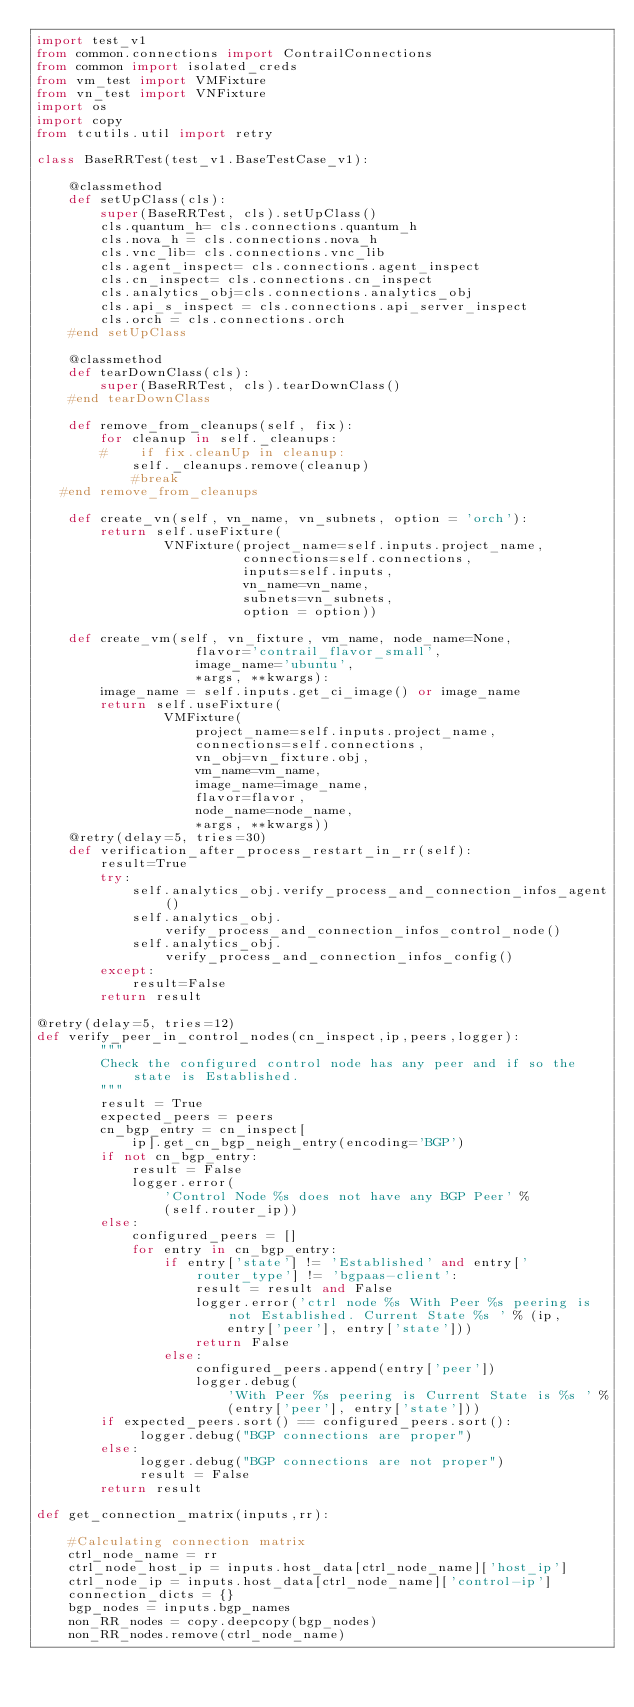<code> <loc_0><loc_0><loc_500><loc_500><_Python_>import test_v1
from common.connections import ContrailConnections
from common import isolated_creds
from vm_test import VMFixture
from vn_test import VNFixture
import os
import copy
from tcutils.util import retry

class BaseRRTest(test_v1.BaseTestCase_v1):

    @classmethod
    def setUpClass(cls):
        super(BaseRRTest, cls).setUpClass()
        cls.quantum_h= cls.connections.quantum_h
        cls.nova_h = cls.connections.nova_h
        cls.vnc_lib= cls.connections.vnc_lib
        cls.agent_inspect= cls.connections.agent_inspect
        cls.cn_inspect= cls.connections.cn_inspect
        cls.analytics_obj=cls.connections.analytics_obj
        cls.api_s_inspect = cls.connections.api_server_inspect
        cls.orch = cls.connections.orch
    #end setUpClass

    @classmethod
    def tearDownClass(cls):
        super(BaseRRTest, cls).tearDownClass()
    #end tearDownClass

    def remove_from_cleanups(self, fix):
        for cleanup in self._cleanups:
        #    if fix.cleanUp in cleanup:
            self._cleanups.remove(cleanup)
            #break
   #end remove_from_cleanups

    def create_vn(self, vn_name, vn_subnets, option = 'orch'):
        return self.useFixture(
                VNFixture(project_name=self.inputs.project_name,
                          connections=self.connections,
                          inputs=self.inputs,
                          vn_name=vn_name,
                          subnets=vn_subnets,
                          option = option))

    def create_vm(self, vn_fixture, vm_name, node_name=None,
                    flavor='contrail_flavor_small',
                    image_name='ubuntu',
                    *args, **kwargs):
        image_name = self.inputs.get_ci_image() or image_name
        return self.useFixture(
                VMFixture(
                    project_name=self.inputs.project_name,
                    connections=self.connections,
                    vn_obj=vn_fixture.obj,
                    vm_name=vm_name,
                    image_name=image_name,
                    flavor=flavor,
                    node_name=node_name,
                    *args, **kwargs))
    @retry(delay=5, tries=30)
    def verification_after_process_restart_in_rr(self):
        result=True
        try:
            self.analytics_obj.verify_process_and_connection_infos_agent()
            self.analytics_obj.verify_process_and_connection_infos_control_node()
            self.analytics_obj.verify_process_and_connection_infos_config()
        except:
            result=False
        return result

@retry(delay=5, tries=12)
def verify_peer_in_control_nodes(cn_inspect,ip,peers,logger):
        """
        Check the configured control node has any peer and if so the state is Established.
        """
        result = True
        expected_peers = peers
        cn_bgp_entry = cn_inspect[
            ip].get_cn_bgp_neigh_entry(encoding='BGP')
        if not cn_bgp_entry:
            result = False
            logger.error(
                'Control Node %s does not have any BGP Peer' %
                (self.router_ip))
        else:
            configured_peers = []
            for entry in cn_bgp_entry:
                if entry['state'] != 'Established' and entry['router_type'] != 'bgpaas-client':
                    result = result and False
                    logger.error('ctrl node %s With Peer %s peering is not Established. Current State %s ' % (ip,
                        entry['peer'], entry['state']))
                    return False
                else:
                    configured_peers.append(entry['peer'])
                    logger.debug(
                        'With Peer %s peering is Current State is %s ' %
                        (entry['peer'], entry['state']))
        if expected_peers.sort() == configured_peers.sort():
             logger.debug("BGP connections are proper")
        else:
             logger.debug("BGP connections are not proper")
             result = False
        return result

def get_connection_matrix(inputs,rr):

    #Calculating connection matrix
    ctrl_node_name = rr
    ctrl_node_host_ip = inputs.host_data[ctrl_node_name]['host_ip']
    ctrl_node_ip = inputs.host_data[ctrl_node_name]['control-ip']
    connection_dicts = {}
    bgp_nodes = inputs.bgp_names
    non_RR_nodes = copy.deepcopy(bgp_nodes)
    non_RR_nodes.remove(ctrl_node_name)</code> 